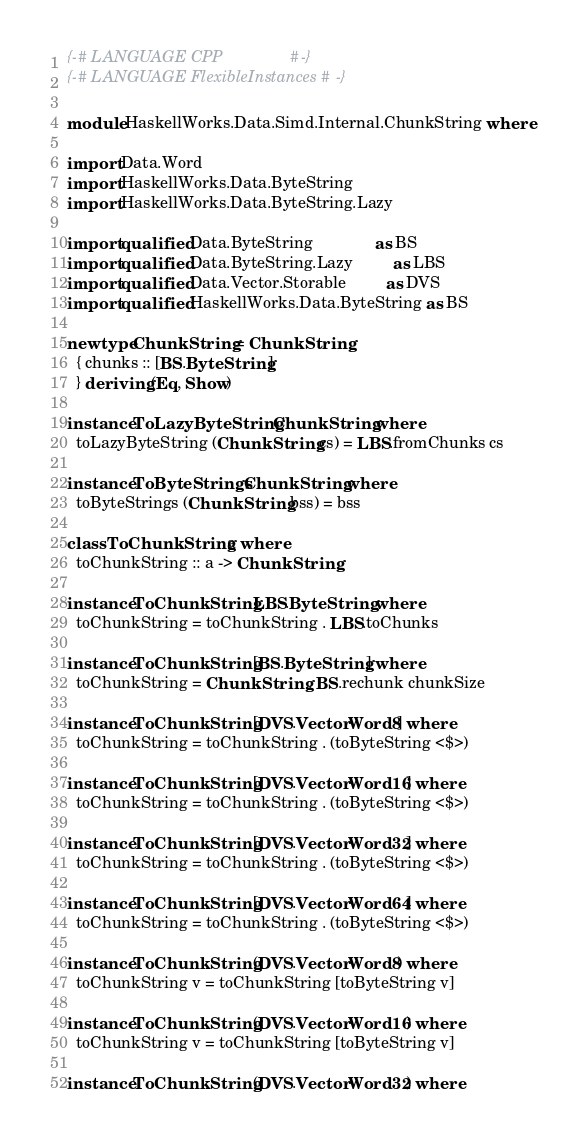<code> <loc_0><loc_0><loc_500><loc_500><_Haskell_>{-# LANGUAGE CPP               #-}
{-# LANGUAGE FlexibleInstances #-}

module HaskellWorks.Data.Simd.Internal.ChunkString where

import Data.Word
import HaskellWorks.Data.ByteString
import HaskellWorks.Data.ByteString.Lazy

import qualified Data.ByteString              as BS
import qualified Data.ByteString.Lazy         as LBS
import qualified Data.Vector.Storable         as DVS
import qualified HaskellWorks.Data.ByteString as BS

newtype ChunkString = ChunkString
  { chunks :: [BS.ByteString]
  } deriving (Eq, Show)

instance ToLazyByteString ChunkString where
  toLazyByteString (ChunkString cs) = LBS.fromChunks cs

instance ToByteStrings ChunkString where
  toByteStrings (ChunkString bss) = bss

class ToChunkString a where
  toChunkString :: a -> ChunkString

instance ToChunkString LBS.ByteString where
  toChunkString = toChunkString . LBS.toChunks

instance ToChunkString [BS.ByteString] where
  toChunkString = ChunkString . BS.rechunk chunkSize

instance ToChunkString [DVS.Vector Word8] where
  toChunkString = toChunkString . (toByteString <$>)

instance ToChunkString [DVS.Vector Word16] where
  toChunkString = toChunkString . (toByteString <$>)

instance ToChunkString [DVS.Vector Word32] where
  toChunkString = toChunkString . (toByteString <$>)

instance ToChunkString [DVS.Vector Word64] where
  toChunkString = toChunkString . (toByteString <$>)

instance ToChunkString (DVS.Vector Word8) where
  toChunkString v = toChunkString [toByteString v]

instance ToChunkString (DVS.Vector Word16) where
  toChunkString v = toChunkString [toByteString v]

instance ToChunkString (DVS.Vector Word32) where</code> 